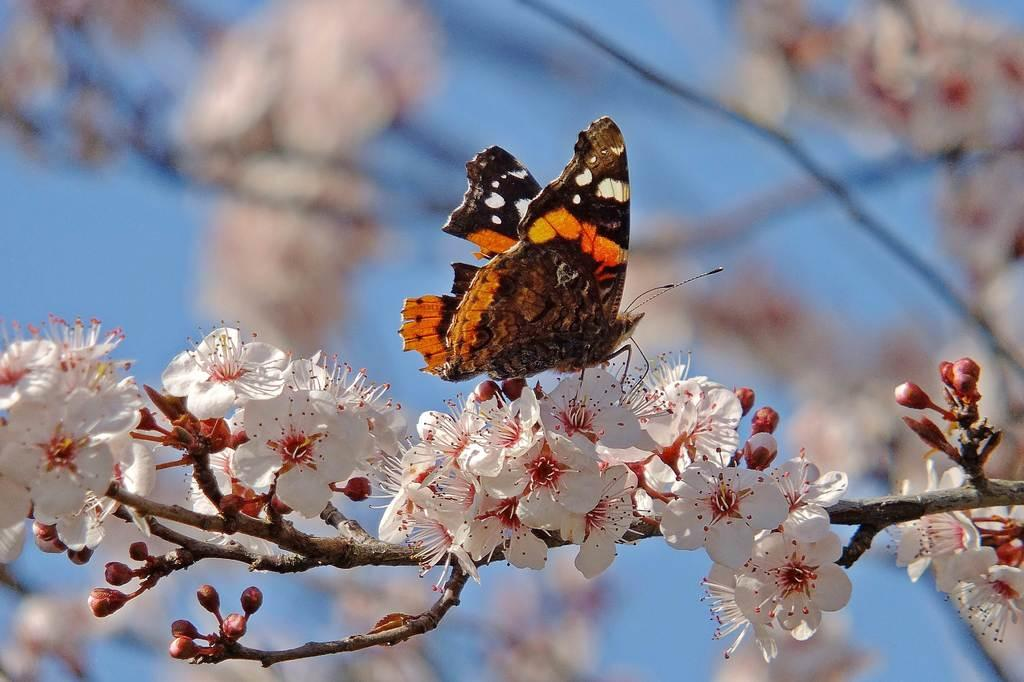What is the main subject of the image? There is a butterfly in the image. Where is the butterfly located? The butterfly is on the flowers of a tree. What can be seen in the background of the image? There is sky visible in the background of the image. What type of dinner is being served in the image? There is no dinner present in the image; it features a butterfly on the flowers of a tree. Is there a crib visible in the image? There is no crib present in the image. 